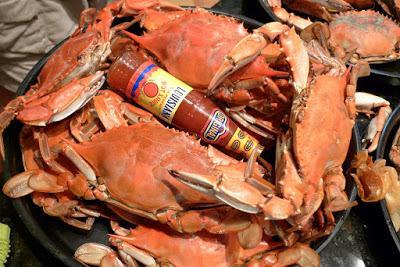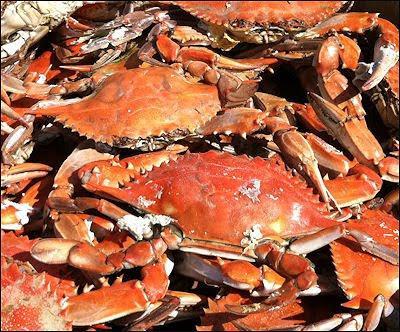The first image is the image on the left, the second image is the image on the right. Examine the images to the left and right. Is the description "The left image shows a pile of forward-facing reddish-orange shell-side up crabs without distinctive spots or a visible container." accurate? Answer yes or no. No. 